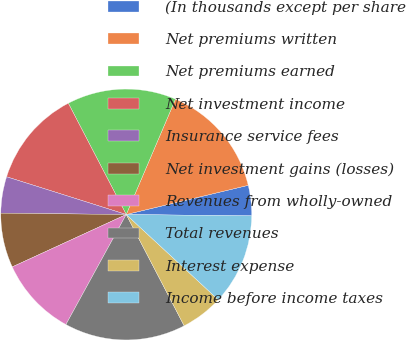<chart> <loc_0><loc_0><loc_500><loc_500><pie_chart><fcel>(In thousands except per share<fcel>Net premiums written<fcel>Net premiums earned<fcel>Net investment income<fcel>Insurance service fees<fcel>Net investment gains (losses)<fcel>Revenues from wholly-owned<fcel>Total revenues<fcel>Interest expense<fcel>Income before income taxes<nl><fcel>3.91%<fcel>14.84%<fcel>14.06%<fcel>12.5%<fcel>4.69%<fcel>7.03%<fcel>10.16%<fcel>15.62%<fcel>5.47%<fcel>11.72%<nl></chart> 